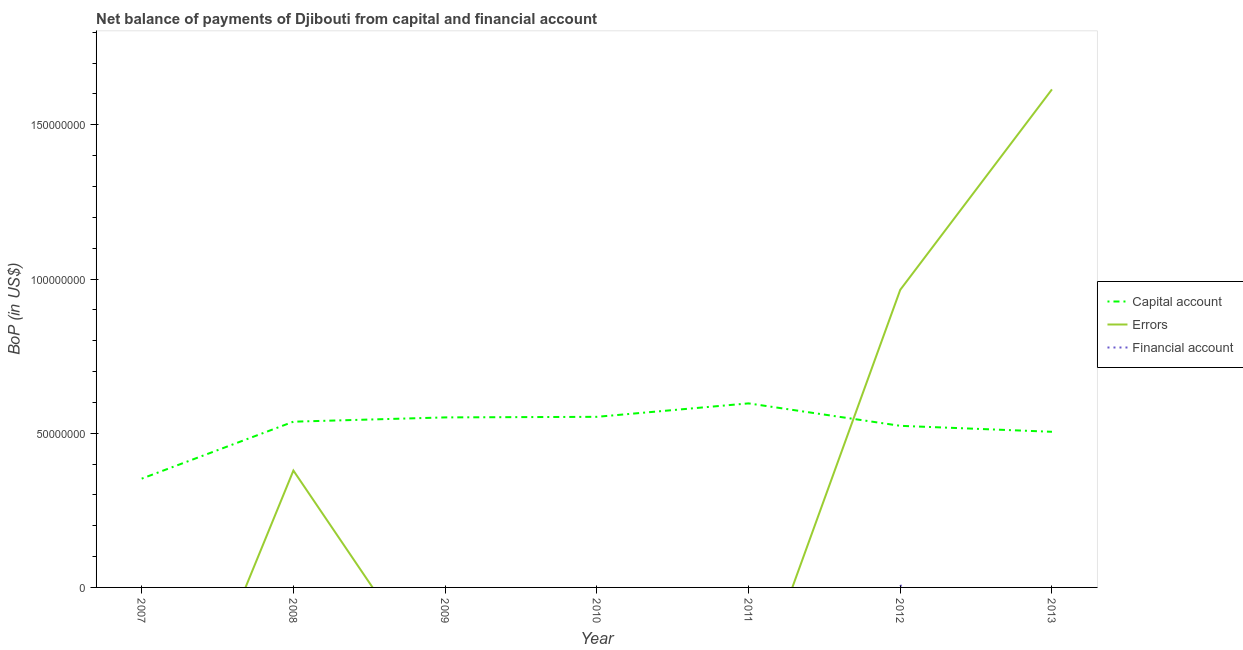How many different coloured lines are there?
Offer a terse response. 3. Is the number of lines equal to the number of legend labels?
Keep it short and to the point. No. What is the amount of financial account in 2010?
Ensure brevity in your answer.  0. Across all years, what is the maximum amount of errors?
Keep it short and to the point. 1.61e+08. In which year was the amount of net capital account maximum?
Offer a very short reply. 2011. What is the total amount of errors in the graph?
Keep it short and to the point. 2.96e+08. What is the difference between the amount of net capital account in 2009 and that in 2010?
Provide a short and direct response. -1.86e+05. What is the difference between the amount of financial account in 2013 and the amount of net capital account in 2008?
Provide a short and direct response. -5.37e+07. What is the average amount of financial account per year?
Your response must be concise. 1.33e+05. In the year 2012, what is the difference between the amount of errors and amount of net capital account?
Offer a very short reply. 4.41e+07. What is the difference between the highest and the second highest amount of net capital account?
Offer a terse response. 4.36e+06. What is the difference between the highest and the lowest amount of errors?
Keep it short and to the point. 1.61e+08. Is it the case that in every year, the sum of the amount of net capital account and amount of errors is greater than the amount of financial account?
Your answer should be very brief. Yes. Is the amount of net capital account strictly greater than the amount of errors over the years?
Provide a succinct answer. No. How many years are there in the graph?
Make the answer very short. 7. Are the values on the major ticks of Y-axis written in scientific E-notation?
Keep it short and to the point. No. Does the graph contain any zero values?
Offer a terse response. Yes. Does the graph contain grids?
Your response must be concise. No. How many legend labels are there?
Give a very brief answer. 3. How are the legend labels stacked?
Your response must be concise. Vertical. What is the title of the graph?
Your response must be concise. Net balance of payments of Djibouti from capital and financial account. Does "Agricultural raw materials" appear as one of the legend labels in the graph?
Give a very brief answer. No. What is the label or title of the Y-axis?
Give a very brief answer. BoP (in US$). What is the BoP (in US$) of Capital account in 2007?
Offer a terse response. 3.53e+07. What is the BoP (in US$) in Financial account in 2007?
Your response must be concise. 0. What is the BoP (in US$) of Capital account in 2008?
Your response must be concise. 5.37e+07. What is the BoP (in US$) of Errors in 2008?
Make the answer very short. 3.79e+07. What is the BoP (in US$) of Capital account in 2009?
Make the answer very short. 5.51e+07. What is the BoP (in US$) in Errors in 2009?
Make the answer very short. 0. What is the BoP (in US$) of Financial account in 2009?
Make the answer very short. 0. What is the BoP (in US$) in Capital account in 2010?
Your answer should be compact. 5.53e+07. What is the BoP (in US$) of Errors in 2010?
Give a very brief answer. 0. What is the BoP (in US$) in Capital account in 2011?
Provide a succinct answer. 5.97e+07. What is the BoP (in US$) in Capital account in 2012?
Your answer should be compact. 5.24e+07. What is the BoP (in US$) in Errors in 2012?
Keep it short and to the point. 9.65e+07. What is the BoP (in US$) of Financial account in 2012?
Your answer should be very brief. 9.34e+05. What is the BoP (in US$) in Capital account in 2013?
Give a very brief answer. 5.05e+07. What is the BoP (in US$) in Errors in 2013?
Offer a terse response. 1.61e+08. Across all years, what is the maximum BoP (in US$) of Capital account?
Offer a terse response. 5.97e+07. Across all years, what is the maximum BoP (in US$) of Errors?
Give a very brief answer. 1.61e+08. Across all years, what is the maximum BoP (in US$) of Financial account?
Give a very brief answer. 9.34e+05. Across all years, what is the minimum BoP (in US$) of Capital account?
Offer a terse response. 3.53e+07. Across all years, what is the minimum BoP (in US$) in Financial account?
Make the answer very short. 0. What is the total BoP (in US$) in Capital account in the graph?
Give a very brief answer. 3.62e+08. What is the total BoP (in US$) of Errors in the graph?
Ensure brevity in your answer.  2.96e+08. What is the total BoP (in US$) in Financial account in the graph?
Provide a short and direct response. 9.34e+05. What is the difference between the BoP (in US$) of Capital account in 2007 and that in 2008?
Offer a very short reply. -1.85e+07. What is the difference between the BoP (in US$) in Capital account in 2007 and that in 2009?
Your answer should be compact. -1.99e+07. What is the difference between the BoP (in US$) in Capital account in 2007 and that in 2010?
Your answer should be very brief. -2.00e+07. What is the difference between the BoP (in US$) of Capital account in 2007 and that in 2011?
Give a very brief answer. -2.44e+07. What is the difference between the BoP (in US$) of Capital account in 2007 and that in 2012?
Give a very brief answer. -1.71e+07. What is the difference between the BoP (in US$) in Capital account in 2007 and that in 2013?
Your answer should be very brief. -1.52e+07. What is the difference between the BoP (in US$) of Capital account in 2008 and that in 2009?
Provide a succinct answer. -1.39e+06. What is the difference between the BoP (in US$) in Capital account in 2008 and that in 2010?
Provide a succinct answer. -1.58e+06. What is the difference between the BoP (in US$) in Capital account in 2008 and that in 2011?
Provide a succinct answer. -5.94e+06. What is the difference between the BoP (in US$) of Capital account in 2008 and that in 2012?
Provide a short and direct response. 1.34e+06. What is the difference between the BoP (in US$) in Errors in 2008 and that in 2012?
Your answer should be compact. -5.86e+07. What is the difference between the BoP (in US$) of Capital account in 2008 and that in 2013?
Your response must be concise. 3.27e+06. What is the difference between the BoP (in US$) of Errors in 2008 and that in 2013?
Provide a short and direct response. -1.24e+08. What is the difference between the BoP (in US$) in Capital account in 2009 and that in 2010?
Provide a succinct answer. -1.86e+05. What is the difference between the BoP (in US$) in Capital account in 2009 and that in 2011?
Provide a short and direct response. -4.55e+06. What is the difference between the BoP (in US$) of Capital account in 2009 and that in 2012?
Offer a very short reply. 2.73e+06. What is the difference between the BoP (in US$) in Capital account in 2009 and that in 2013?
Provide a short and direct response. 4.66e+06. What is the difference between the BoP (in US$) of Capital account in 2010 and that in 2011?
Give a very brief answer. -4.36e+06. What is the difference between the BoP (in US$) in Capital account in 2010 and that in 2012?
Your answer should be compact. 2.91e+06. What is the difference between the BoP (in US$) of Capital account in 2010 and that in 2013?
Your answer should be very brief. 4.85e+06. What is the difference between the BoP (in US$) of Capital account in 2011 and that in 2012?
Offer a very short reply. 7.28e+06. What is the difference between the BoP (in US$) of Capital account in 2011 and that in 2013?
Offer a very short reply. 9.21e+06. What is the difference between the BoP (in US$) in Capital account in 2012 and that in 2013?
Keep it short and to the point. 1.94e+06. What is the difference between the BoP (in US$) of Errors in 2012 and that in 2013?
Offer a terse response. -6.50e+07. What is the difference between the BoP (in US$) of Capital account in 2007 and the BoP (in US$) of Errors in 2008?
Provide a succinct answer. -2.63e+06. What is the difference between the BoP (in US$) in Capital account in 2007 and the BoP (in US$) in Errors in 2012?
Your answer should be compact. -6.12e+07. What is the difference between the BoP (in US$) of Capital account in 2007 and the BoP (in US$) of Financial account in 2012?
Provide a short and direct response. 3.43e+07. What is the difference between the BoP (in US$) in Capital account in 2007 and the BoP (in US$) in Errors in 2013?
Ensure brevity in your answer.  -1.26e+08. What is the difference between the BoP (in US$) in Capital account in 2008 and the BoP (in US$) in Errors in 2012?
Keep it short and to the point. -4.28e+07. What is the difference between the BoP (in US$) in Capital account in 2008 and the BoP (in US$) in Financial account in 2012?
Offer a terse response. 5.28e+07. What is the difference between the BoP (in US$) in Errors in 2008 and the BoP (in US$) in Financial account in 2012?
Provide a succinct answer. 3.70e+07. What is the difference between the BoP (in US$) in Capital account in 2008 and the BoP (in US$) in Errors in 2013?
Your response must be concise. -1.08e+08. What is the difference between the BoP (in US$) in Capital account in 2009 and the BoP (in US$) in Errors in 2012?
Ensure brevity in your answer.  -4.14e+07. What is the difference between the BoP (in US$) in Capital account in 2009 and the BoP (in US$) in Financial account in 2012?
Provide a succinct answer. 5.42e+07. What is the difference between the BoP (in US$) in Capital account in 2009 and the BoP (in US$) in Errors in 2013?
Give a very brief answer. -1.06e+08. What is the difference between the BoP (in US$) in Capital account in 2010 and the BoP (in US$) in Errors in 2012?
Ensure brevity in your answer.  -4.12e+07. What is the difference between the BoP (in US$) of Capital account in 2010 and the BoP (in US$) of Financial account in 2012?
Make the answer very short. 5.44e+07. What is the difference between the BoP (in US$) of Capital account in 2010 and the BoP (in US$) of Errors in 2013?
Give a very brief answer. -1.06e+08. What is the difference between the BoP (in US$) of Capital account in 2011 and the BoP (in US$) of Errors in 2012?
Your answer should be very brief. -3.68e+07. What is the difference between the BoP (in US$) of Capital account in 2011 and the BoP (in US$) of Financial account in 2012?
Your response must be concise. 5.87e+07. What is the difference between the BoP (in US$) in Capital account in 2011 and the BoP (in US$) in Errors in 2013?
Make the answer very short. -1.02e+08. What is the difference between the BoP (in US$) of Capital account in 2012 and the BoP (in US$) of Errors in 2013?
Your answer should be compact. -1.09e+08. What is the average BoP (in US$) of Capital account per year?
Provide a succinct answer. 5.17e+07. What is the average BoP (in US$) of Errors per year?
Your response must be concise. 4.23e+07. What is the average BoP (in US$) of Financial account per year?
Provide a succinct answer. 1.33e+05. In the year 2008, what is the difference between the BoP (in US$) of Capital account and BoP (in US$) of Errors?
Your response must be concise. 1.58e+07. In the year 2012, what is the difference between the BoP (in US$) in Capital account and BoP (in US$) in Errors?
Give a very brief answer. -4.41e+07. In the year 2012, what is the difference between the BoP (in US$) in Capital account and BoP (in US$) in Financial account?
Give a very brief answer. 5.15e+07. In the year 2012, what is the difference between the BoP (in US$) in Errors and BoP (in US$) in Financial account?
Your response must be concise. 9.56e+07. In the year 2013, what is the difference between the BoP (in US$) in Capital account and BoP (in US$) in Errors?
Your answer should be very brief. -1.11e+08. What is the ratio of the BoP (in US$) of Capital account in 2007 to that in 2008?
Ensure brevity in your answer.  0.66. What is the ratio of the BoP (in US$) in Capital account in 2007 to that in 2009?
Keep it short and to the point. 0.64. What is the ratio of the BoP (in US$) of Capital account in 2007 to that in 2010?
Give a very brief answer. 0.64. What is the ratio of the BoP (in US$) in Capital account in 2007 to that in 2011?
Offer a terse response. 0.59. What is the ratio of the BoP (in US$) in Capital account in 2007 to that in 2012?
Keep it short and to the point. 0.67. What is the ratio of the BoP (in US$) in Capital account in 2007 to that in 2013?
Your response must be concise. 0.7. What is the ratio of the BoP (in US$) of Capital account in 2008 to that in 2009?
Give a very brief answer. 0.97. What is the ratio of the BoP (in US$) of Capital account in 2008 to that in 2010?
Offer a very short reply. 0.97. What is the ratio of the BoP (in US$) of Capital account in 2008 to that in 2011?
Give a very brief answer. 0.9. What is the ratio of the BoP (in US$) of Capital account in 2008 to that in 2012?
Give a very brief answer. 1.03. What is the ratio of the BoP (in US$) of Errors in 2008 to that in 2012?
Your answer should be compact. 0.39. What is the ratio of the BoP (in US$) of Capital account in 2008 to that in 2013?
Your answer should be very brief. 1.06. What is the ratio of the BoP (in US$) of Errors in 2008 to that in 2013?
Your answer should be compact. 0.23. What is the ratio of the BoP (in US$) of Capital account in 2009 to that in 2010?
Your response must be concise. 1. What is the ratio of the BoP (in US$) in Capital account in 2009 to that in 2011?
Provide a short and direct response. 0.92. What is the ratio of the BoP (in US$) in Capital account in 2009 to that in 2012?
Offer a very short reply. 1.05. What is the ratio of the BoP (in US$) in Capital account in 2009 to that in 2013?
Provide a short and direct response. 1.09. What is the ratio of the BoP (in US$) in Capital account in 2010 to that in 2011?
Make the answer very short. 0.93. What is the ratio of the BoP (in US$) in Capital account in 2010 to that in 2012?
Your response must be concise. 1.06. What is the ratio of the BoP (in US$) in Capital account in 2010 to that in 2013?
Make the answer very short. 1.1. What is the ratio of the BoP (in US$) in Capital account in 2011 to that in 2012?
Your answer should be very brief. 1.14. What is the ratio of the BoP (in US$) of Capital account in 2011 to that in 2013?
Keep it short and to the point. 1.18. What is the ratio of the BoP (in US$) in Capital account in 2012 to that in 2013?
Make the answer very short. 1.04. What is the ratio of the BoP (in US$) in Errors in 2012 to that in 2013?
Your answer should be very brief. 0.6. What is the difference between the highest and the second highest BoP (in US$) of Capital account?
Offer a very short reply. 4.36e+06. What is the difference between the highest and the second highest BoP (in US$) in Errors?
Your answer should be very brief. 6.50e+07. What is the difference between the highest and the lowest BoP (in US$) of Capital account?
Offer a terse response. 2.44e+07. What is the difference between the highest and the lowest BoP (in US$) in Errors?
Offer a very short reply. 1.61e+08. What is the difference between the highest and the lowest BoP (in US$) of Financial account?
Offer a terse response. 9.34e+05. 